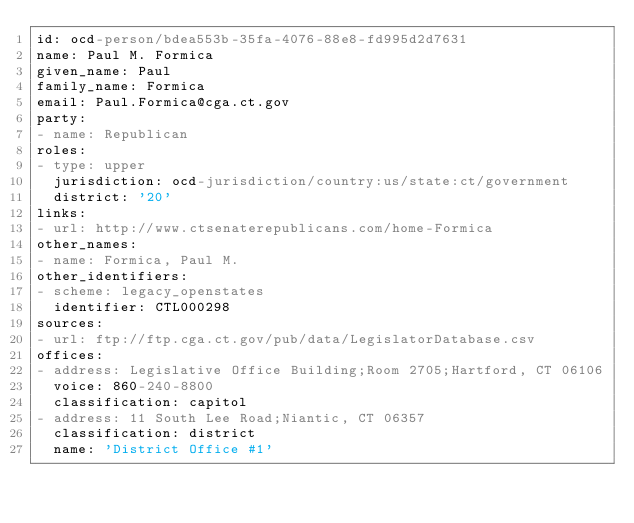Convert code to text. <code><loc_0><loc_0><loc_500><loc_500><_YAML_>id: ocd-person/bdea553b-35fa-4076-88e8-fd995d2d7631
name: Paul M. Formica
given_name: Paul
family_name: Formica
email: Paul.Formica@cga.ct.gov
party:
- name: Republican
roles:
- type: upper
  jurisdiction: ocd-jurisdiction/country:us/state:ct/government
  district: '20'
links:
- url: http://www.ctsenaterepublicans.com/home-Formica
other_names:
- name: Formica, Paul M.
other_identifiers:
- scheme: legacy_openstates
  identifier: CTL000298
sources:
- url: ftp://ftp.cga.ct.gov/pub/data/LegislatorDatabase.csv
offices:
- address: Legislative Office Building;Room 2705;Hartford, CT 06106
  voice: 860-240-8800
  classification: capitol
- address: 11 South Lee Road;Niantic, CT 06357
  classification: district
  name: 'District Office #1'
</code> 